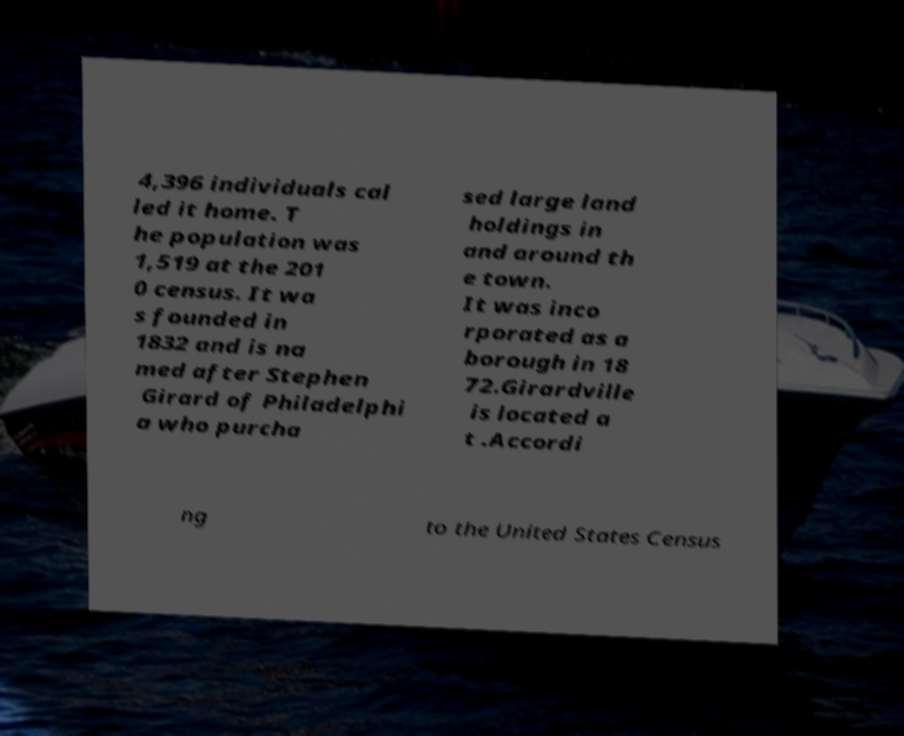Could you assist in decoding the text presented in this image and type it out clearly? 4,396 individuals cal led it home. T he population was 1,519 at the 201 0 census. It wa s founded in 1832 and is na med after Stephen Girard of Philadelphi a who purcha sed large land holdings in and around th e town. It was inco rporated as a borough in 18 72.Girardville is located a t .Accordi ng to the United States Census 